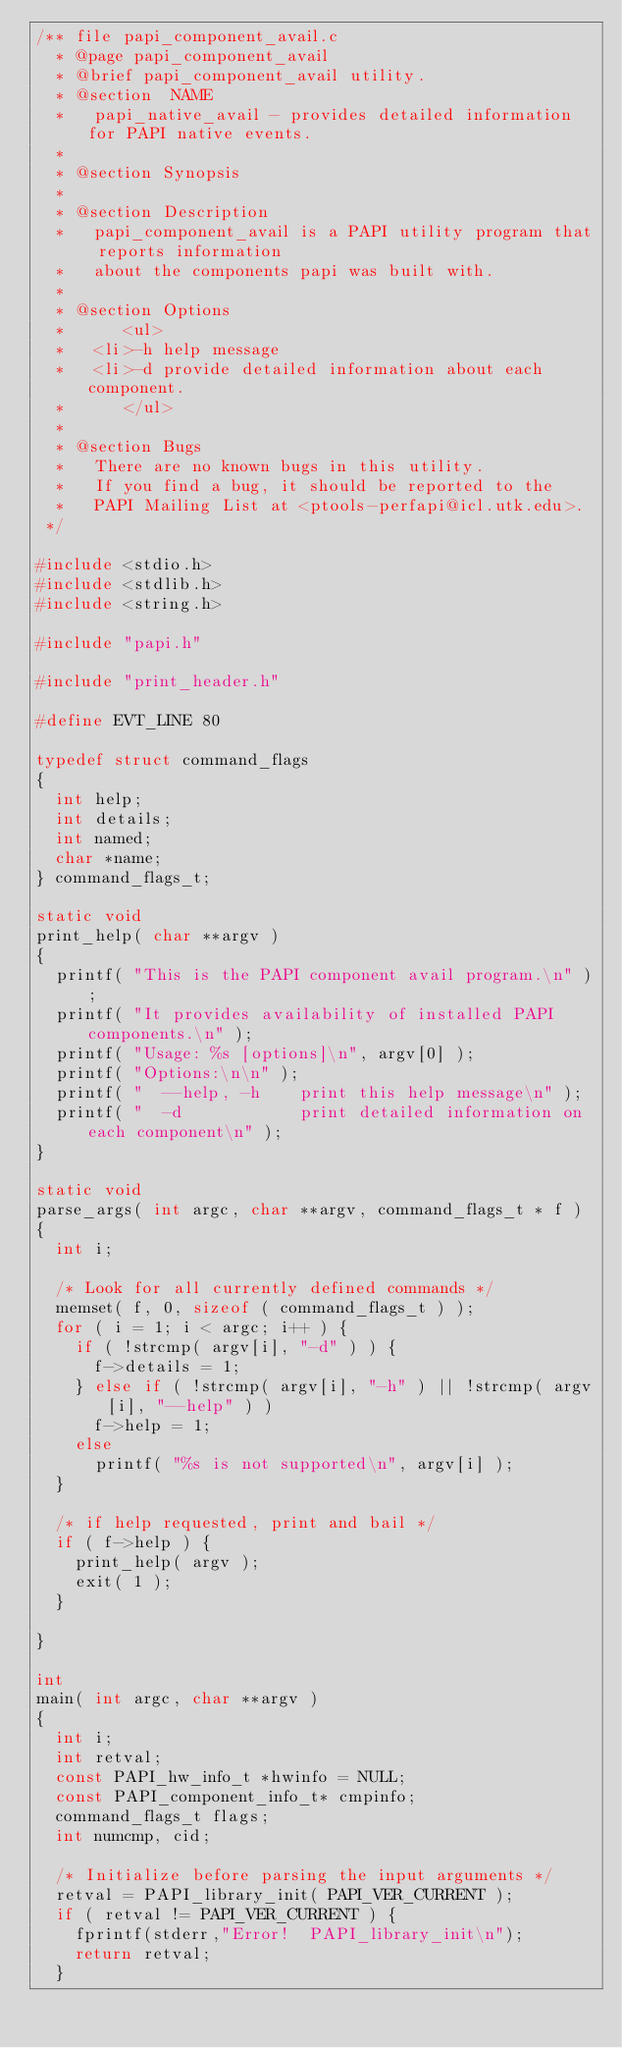Convert code to text. <code><loc_0><loc_0><loc_500><loc_500><_C_>/** file papi_component_avail.c
  *	@page papi_component_avail
  * @brief papi_component_avail utility.
  *	@section  NAME
  *		papi_native_avail - provides detailed information for PAPI native events. 
  *
  *	@section Synopsis
  *
  *	@section Description
  *		papi_component_avail is a PAPI utility program that reports information 
  *		about the components papi was built with.
  *
  *	@section Options
  *      <ul>
  *		<li>-h help message
  *		<li>-d provide detailed information about each component.
  *      </ul>
  *
  *	@section Bugs
  *		There are no known bugs in this utility.
  *		If you find a bug, it should be reported to the
  *		PAPI Mailing List at <ptools-perfapi@icl.utk.edu>.
 */

#include <stdio.h>
#include <stdlib.h>
#include <string.h>

#include "papi.h"

#include "print_header.h"

#define EVT_LINE 80

typedef struct command_flags
{
	int help;
	int details;
	int named;
	char *name;
} command_flags_t;

static void
print_help( char **argv )
{
	printf( "This is the PAPI component avail program.\n" );
	printf( "It provides availability of installed PAPI components.\n" );
	printf( "Usage: %s [options]\n", argv[0] );
	printf( "Options:\n\n" );
	printf( "  --help, -h    print this help message\n" );
	printf( "  -d            print detailed information on each component\n" );
}

static void
parse_args( int argc, char **argv, command_flags_t * f )
{
	int i;

	/* Look for all currently defined commands */
	memset( f, 0, sizeof ( command_flags_t ) );
	for ( i = 1; i < argc; i++ ) {
		if ( !strcmp( argv[i], "-d" ) ) {
			f->details = 1;
		} else if ( !strcmp( argv[i], "-h" ) || !strcmp( argv[i], "--help" ) )
			f->help = 1;
		else
			printf( "%s is not supported\n", argv[i] );
	}

	/* if help requested, print and bail */
	if ( f->help ) {
		print_help( argv );
		exit( 1 );
	}

}

int
main( int argc, char **argv )
{
	int i;
	int retval;
	const PAPI_hw_info_t *hwinfo = NULL;
	const PAPI_component_info_t* cmpinfo;
	command_flags_t flags;
	int numcmp, cid;

	/* Initialize before parsing the input arguments */
	retval = PAPI_library_init( PAPI_VER_CURRENT );
	if ( retval != PAPI_VER_CURRENT ) {
		fprintf(stderr,"Error!  PAPI_library_init\n");
		return retval;
	}
</code> 